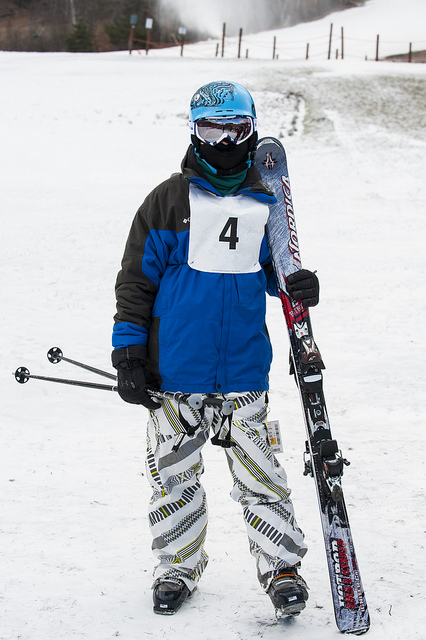Extract all visible text content from this image. 4 